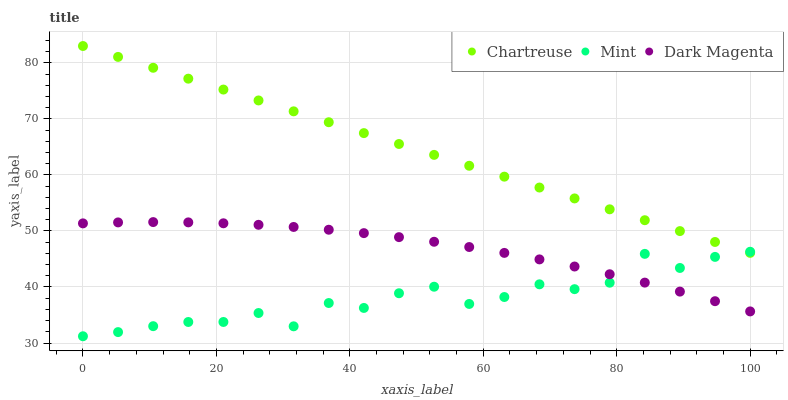Does Mint have the minimum area under the curve?
Answer yes or no. Yes. Does Chartreuse have the maximum area under the curve?
Answer yes or no. Yes. Does Dark Magenta have the minimum area under the curve?
Answer yes or no. No. Does Dark Magenta have the maximum area under the curve?
Answer yes or no. No. Is Chartreuse the smoothest?
Answer yes or no. Yes. Is Mint the roughest?
Answer yes or no. Yes. Is Dark Magenta the smoothest?
Answer yes or no. No. Is Dark Magenta the roughest?
Answer yes or no. No. Does Mint have the lowest value?
Answer yes or no. Yes. Does Dark Magenta have the lowest value?
Answer yes or no. No. Does Chartreuse have the highest value?
Answer yes or no. Yes. Does Dark Magenta have the highest value?
Answer yes or no. No. Is Dark Magenta less than Chartreuse?
Answer yes or no. Yes. Is Chartreuse greater than Dark Magenta?
Answer yes or no. Yes. Does Mint intersect Dark Magenta?
Answer yes or no. Yes. Is Mint less than Dark Magenta?
Answer yes or no. No. Is Mint greater than Dark Magenta?
Answer yes or no. No. Does Dark Magenta intersect Chartreuse?
Answer yes or no. No. 